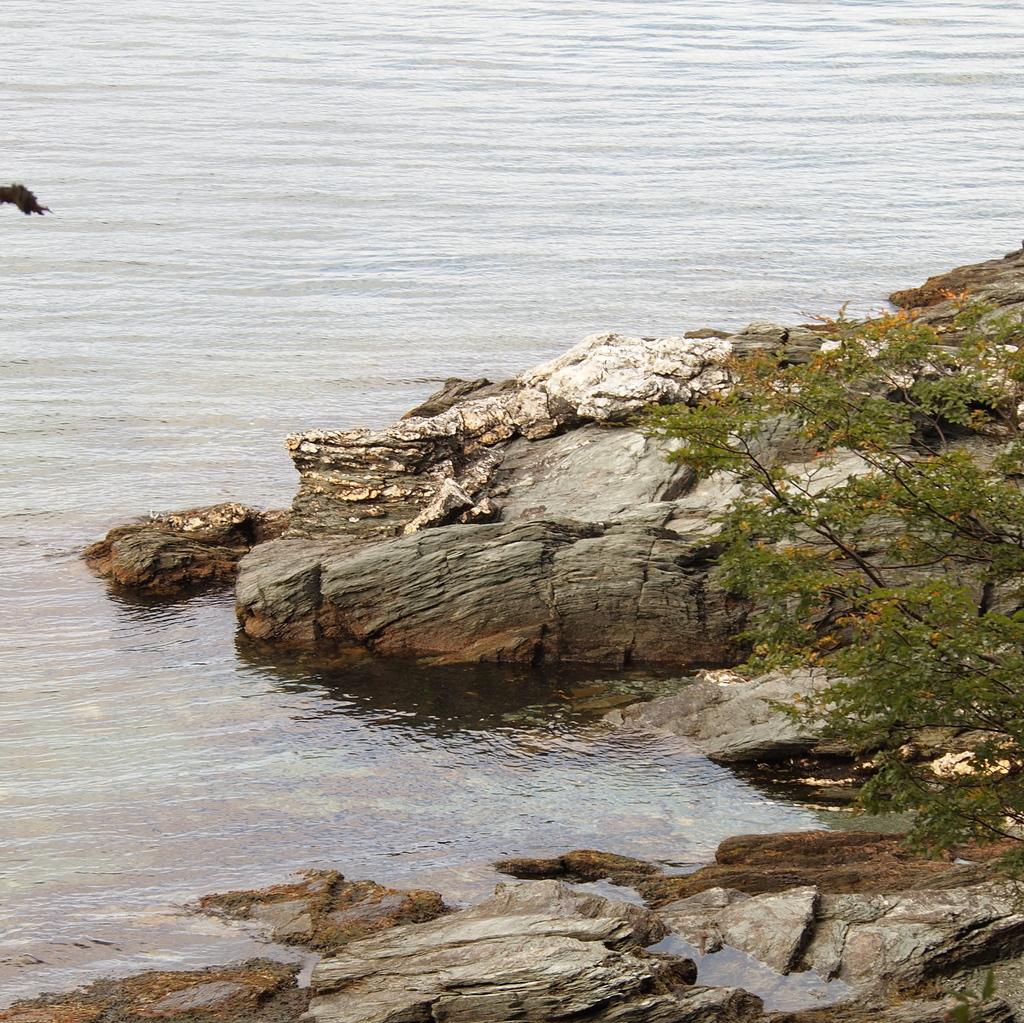What type of vegetation can be seen in the image? There are trees in the image. What other objects can be seen in the image? There are stones in the image. What can be seen in the background of the image? There is water visible in the background of the image. Can you tell me how many pieces of cheese are on the trees in the image? There is no cheese present in the image; it features trees and stones. What type of farmer is shown working in the image? There is no farmer present in the image; it only shows trees, stones, and water in the background. 